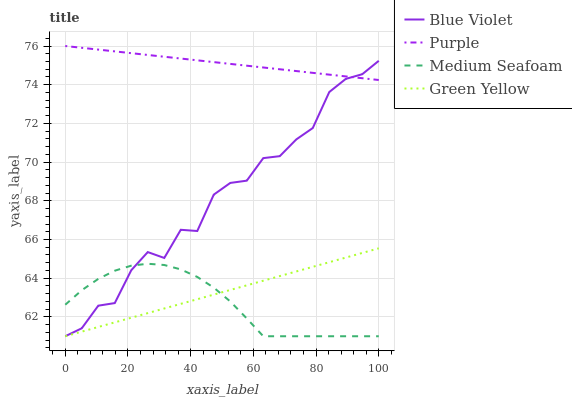Does Medium Seafoam have the minimum area under the curve?
Answer yes or no. Yes. Does Purple have the maximum area under the curve?
Answer yes or no. Yes. Does Green Yellow have the minimum area under the curve?
Answer yes or no. No. Does Green Yellow have the maximum area under the curve?
Answer yes or no. No. Is Purple the smoothest?
Answer yes or no. Yes. Is Blue Violet the roughest?
Answer yes or no. Yes. Is Green Yellow the smoothest?
Answer yes or no. No. Is Green Yellow the roughest?
Answer yes or no. No. Does Purple have the highest value?
Answer yes or no. Yes. Does Green Yellow have the highest value?
Answer yes or no. No. Is Medium Seafoam less than Purple?
Answer yes or no. Yes. Is Purple greater than Green Yellow?
Answer yes or no. Yes. Does Purple intersect Blue Violet?
Answer yes or no. Yes. Is Purple less than Blue Violet?
Answer yes or no. No. Is Purple greater than Blue Violet?
Answer yes or no. No. Does Medium Seafoam intersect Purple?
Answer yes or no. No. 